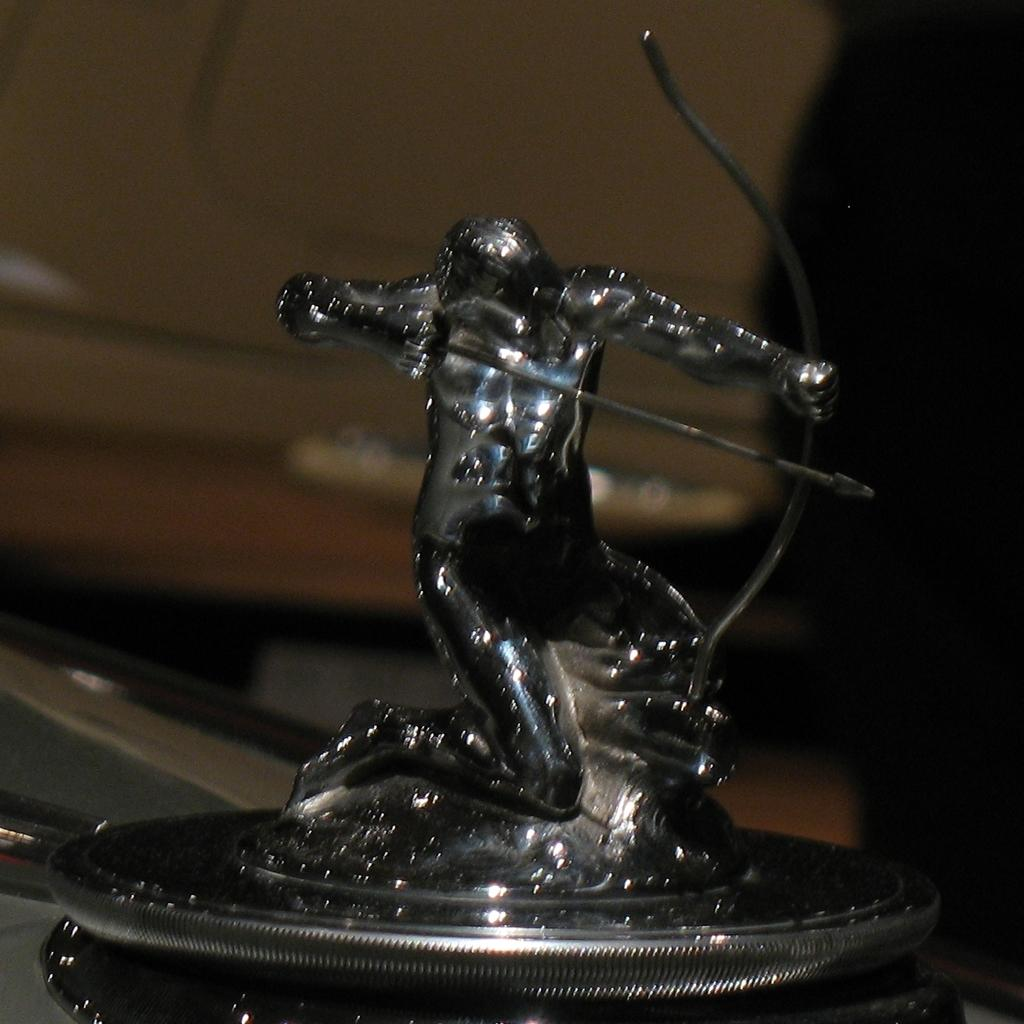What is the main subject of the image? There is a sculpture of a person in the image. What is the person holding in their hands? The person is holding a bow in one hand and an arrow in the other hand. Can you describe the background of the image? The background of the image is blurred. What type of circle can be seen on the person's tongue in the image? There is no person or tongue present in the image; it features a sculpture of a person holding a bow and an arrow. 